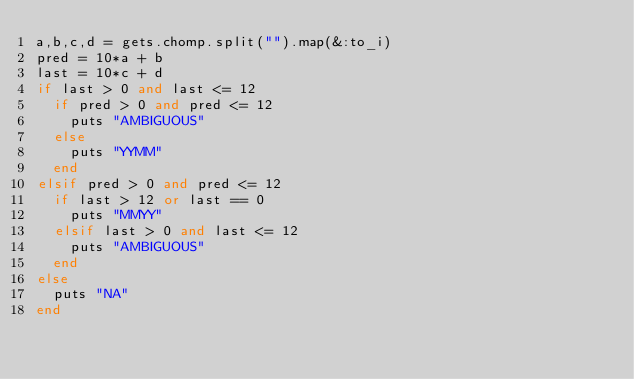<code> <loc_0><loc_0><loc_500><loc_500><_Ruby_>a,b,c,d = gets.chomp.split("").map(&:to_i)
pred = 10*a + b
last = 10*c + d
if last > 0 and last <= 12
  if pred > 0 and pred <= 12
    puts "AMBIGUOUS"
  else
    puts "YYMM"
  end
elsif pred > 0 and pred <= 12
  if last > 12 or last == 0
    puts "MMYY"
  elsif last > 0 and last <= 12
    puts "AMBIGUOUS"
  end
else
  puts "NA"
end</code> 